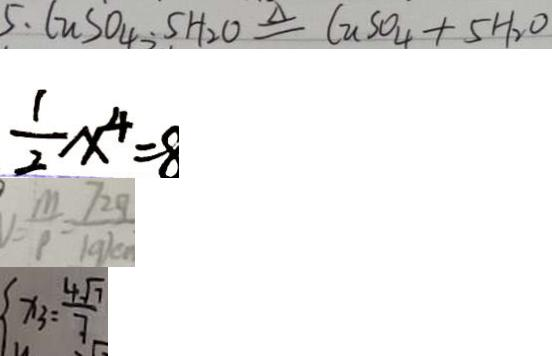<formula> <loc_0><loc_0><loc_500><loc_500>5 . C u S O _ { 4 } \cdot 5 H _ { 2 } O \xlongequal { \Delta } C u S O _ { 4 } + 5 H _ { 2 } O 
 \frac { 1 } { 2 } x ^ { 4 } = 8 
 1 = \frac { m } { p } = \frac { 7 2 g } { 1 9 k m } 
 x _ { 3 } = \frac { 4 \sqrt { 7 } } { 7 }</formula> 